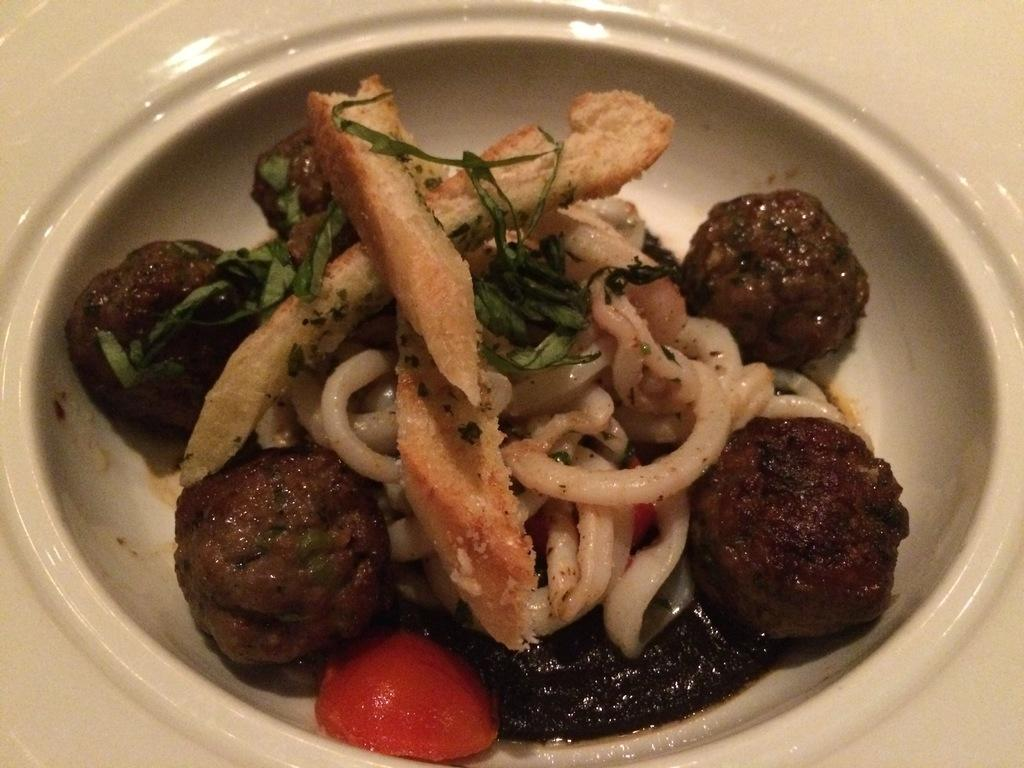What type of food can be seen in the image? There are meatballs and bread slices in the image. What else is present in the image besides meatballs and bread slices? There are noodles in a bowl in the image. What shape is the giraffe in the image? There is no giraffe present in the image. 